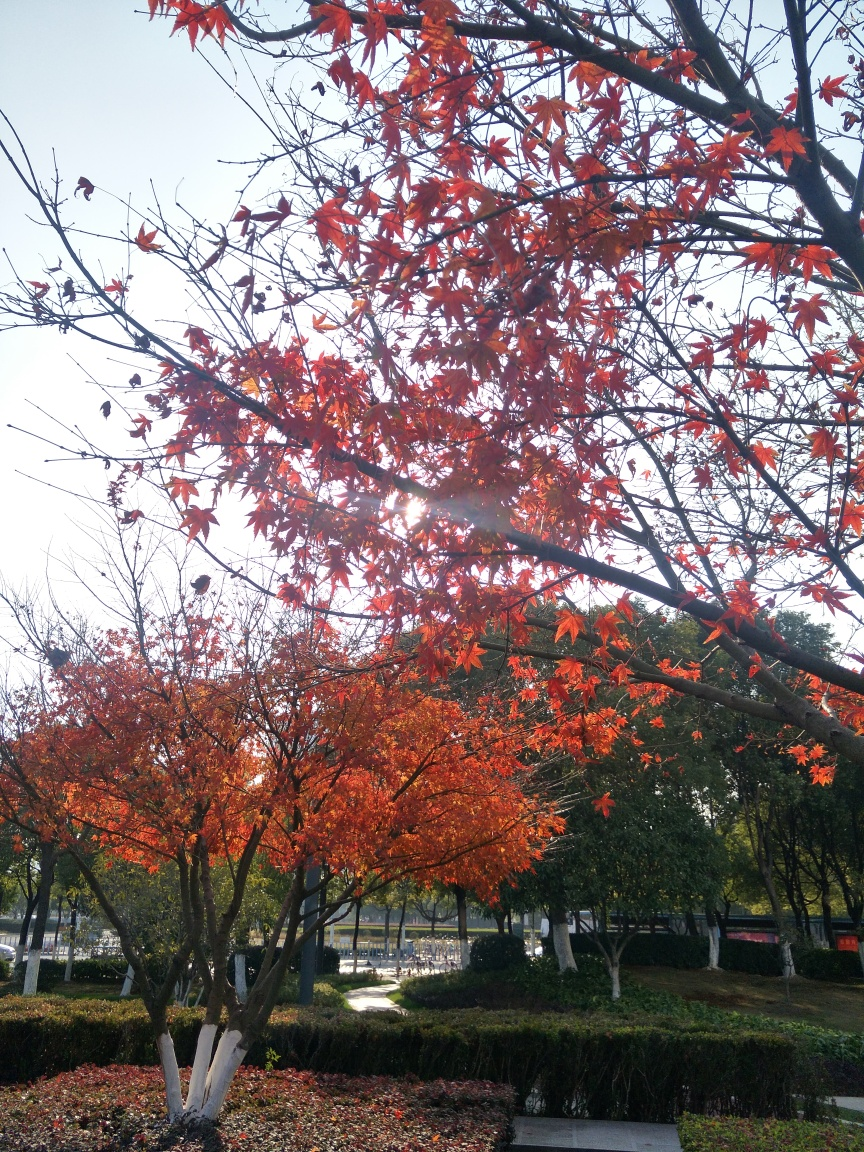What type of trees are in this image? While specific tree identification can be challenging without clearer views of the leaves’ shapes and bark textures, the trees in the image feature characteristically red and orange leaves, which could suggest they are a variety of maple. 